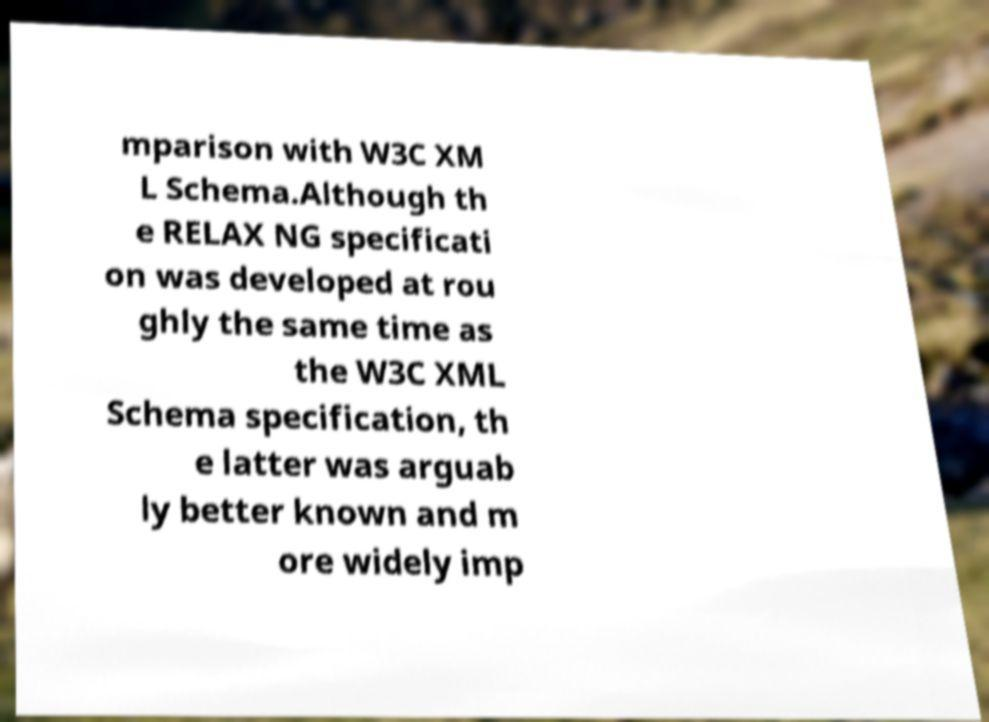For documentation purposes, I need the text within this image transcribed. Could you provide that? mparison with W3C XM L Schema.Although th e RELAX NG specificati on was developed at rou ghly the same time as the W3C XML Schema specification, th e latter was arguab ly better known and m ore widely imp 